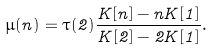<formula> <loc_0><loc_0><loc_500><loc_500>\mu ( n ) = \tau ( 2 ) \frac { K [ n ] - n K [ 1 ] } { K [ 2 ] - 2 K [ 1 ] } .</formula> 